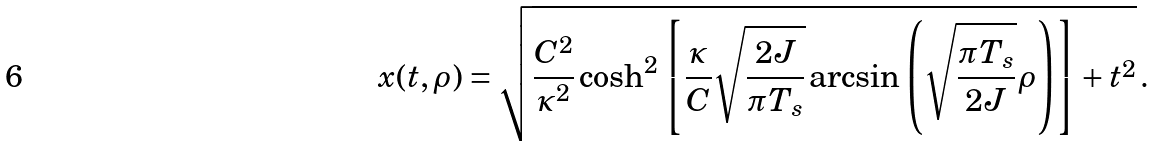<formula> <loc_0><loc_0><loc_500><loc_500>x ( t , \rho ) = \sqrt { \frac { C ^ { 2 } } { \kappa ^ { 2 } } \cosh ^ { 2 } \left [ \frac { \kappa } { C } \sqrt { \frac { 2 J } { \pi T _ { s } } } \arcsin \left ( \sqrt { \frac { \pi T _ { s } } { 2 J } } \rho \right ) \right ] + t ^ { 2 } } \, .</formula> 